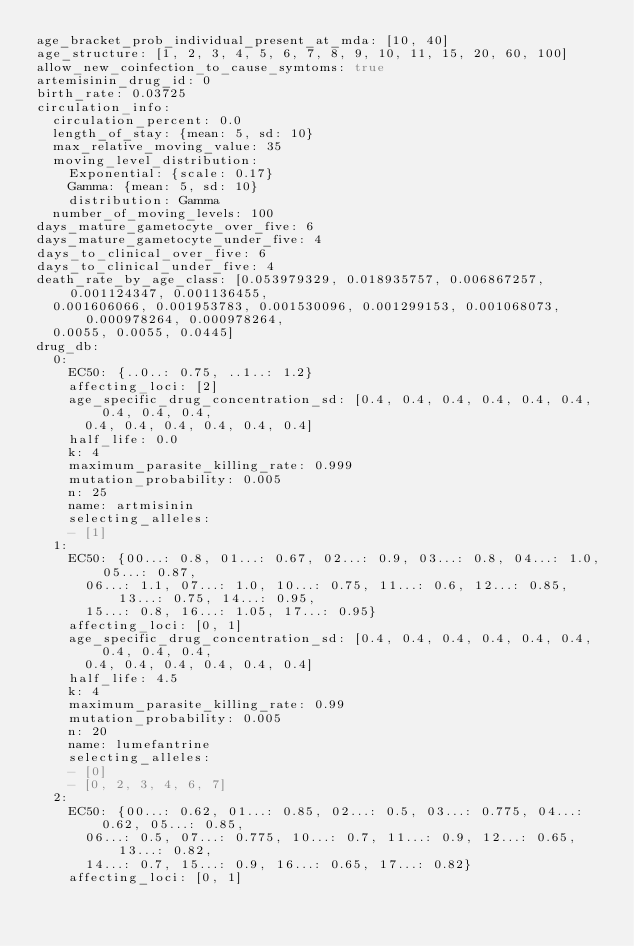Convert code to text. <code><loc_0><loc_0><loc_500><loc_500><_YAML_>age_bracket_prob_individual_present_at_mda: [10, 40]
age_structure: [1, 2, 3, 4, 5, 6, 7, 8, 9, 10, 11, 15, 20, 60, 100]
allow_new_coinfection_to_cause_symtoms: true
artemisinin_drug_id: 0
birth_rate: 0.03725
circulation_info:
  circulation_percent: 0.0
  length_of_stay: {mean: 5, sd: 10}
  max_relative_moving_value: 35
  moving_level_distribution:
    Exponential: {scale: 0.17}
    Gamma: {mean: 5, sd: 10}
    distribution: Gamma
  number_of_moving_levels: 100
days_mature_gametocyte_over_five: 6
days_mature_gametocyte_under_five: 4
days_to_clinical_over_five: 6
days_to_clinical_under_five: 4
death_rate_by_age_class: [0.053979329, 0.018935757, 0.006867257, 0.001124347, 0.001136455,
  0.001606066, 0.001953783, 0.001530096, 0.001299153, 0.001068073, 0.000978264, 0.000978264,
  0.0055, 0.0055, 0.0445]
drug_db:
  0:
    EC50: {..0..: 0.75, ..1..: 1.2}
    affecting_loci: [2]
    age_specific_drug_concentration_sd: [0.4, 0.4, 0.4, 0.4, 0.4, 0.4, 0.4, 0.4, 0.4,
      0.4, 0.4, 0.4, 0.4, 0.4, 0.4]
    half_life: 0.0
    k: 4
    maximum_parasite_killing_rate: 0.999
    mutation_probability: 0.005
    n: 25
    name: artmisinin
    selecting_alleles:
    - [1]
  1:
    EC50: {00...: 0.8, 01...: 0.67, 02...: 0.9, 03...: 0.8, 04...: 1.0, 05...: 0.87,
      06...: 1.1, 07...: 1.0, 10...: 0.75, 11...: 0.6, 12...: 0.85, 13...: 0.75, 14...: 0.95,
      15...: 0.8, 16...: 1.05, 17...: 0.95}
    affecting_loci: [0, 1]
    age_specific_drug_concentration_sd: [0.4, 0.4, 0.4, 0.4, 0.4, 0.4, 0.4, 0.4, 0.4,
      0.4, 0.4, 0.4, 0.4, 0.4, 0.4]
    half_life: 4.5
    k: 4
    maximum_parasite_killing_rate: 0.99
    mutation_probability: 0.005
    n: 20
    name: lumefantrine
    selecting_alleles:
    - [0]
    - [0, 2, 3, 4, 6, 7]
  2:
    EC50: {00...: 0.62, 01...: 0.85, 02...: 0.5, 03...: 0.775, 04...: 0.62, 05...: 0.85,
      06...: 0.5, 07...: 0.775, 10...: 0.7, 11...: 0.9, 12...: 0.65, 13...: 0.82,
      14...: 0.7, 15...: 0.9, 16...: 0.65, 17...: 0.82}
    affecting_loci: [0, 1]</code> 